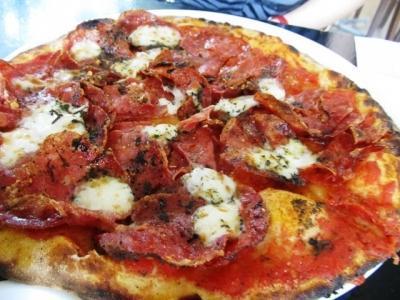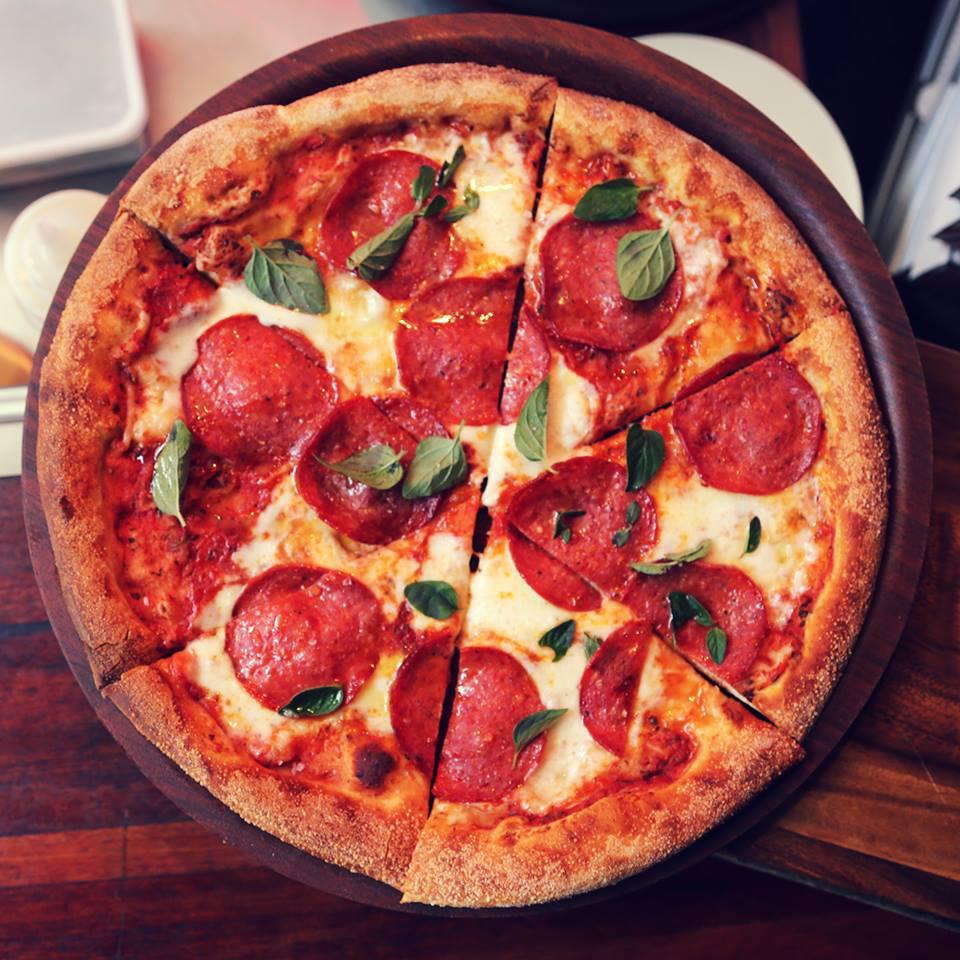The first image is the image on the left, the second image is the image on the right. For the images shown, is this caption "There are more pizzas in the image on the right." true? Answer yes or no. No. The first image is the image on the left, the second image is the image on the right. For the images displayed, is the sentence "The left image contains one pizza on a round wooden tray, which has at least one slice out of place." factually correct? Answer yes or no. No. 